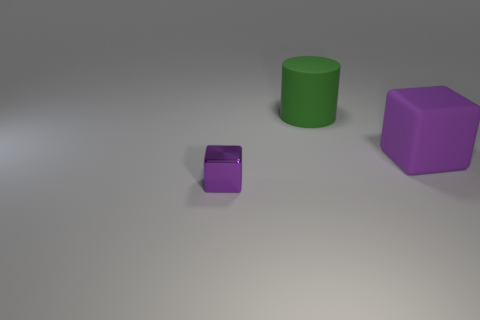Subtract all yellow cylinders. Subtract all purple spheres. How many cylinders are left? 1 Subtract all purple cylinders. How many yellow blocks are left? 0 Add 1 big greens. How many small objects exist? 0 Subtract all big purple rubber things. Subtract all tiny rubber blocks. How many objects are left? 2 Add 2 shiny things. How many shiny things are left? 3 Add 2 purple objects. How many purple objects exist? 4 Add 1 tiny brown things. How many objects exist? 4 Subtract 0 red spheres. How many objects are left? 3 How many purple cubes must be subtracted to get 1 purple cubes? 1 Subtract all cubes. How many objects are left? 1 